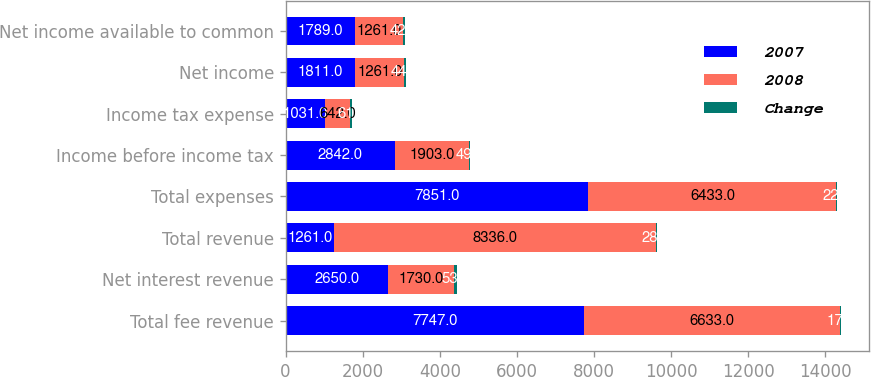<chart> <loc_0><loc_0><loc_500><loc_500><stacked_bar_chart><ecel><fcel>Total fee revenue<fcel>Net interest revenue<fcel>Total revenue<fcel>Total expenses<fcel>Income before income tax<fcel>Income tax expense<fcel>Net income<fcel>Net income available to common<nl><fcel>2007<fcel>7747<fcel>2650<fcel>1261<fcel>7851<fcel>2842<fcel>1031<fcel>1811<fcel>1789<nl><fcel>2008<fcel>6633<fcel>1730<fcel>8336<fcel>6433<fcel>1903<fcel>642<fcel>1261<fcel>1261<nl><fcel>Change<fcel>17<fcel>53<fcel>28<fcel>22<fcel>49<fcel>61<fcel>44<fcel>42<nl></chart> 